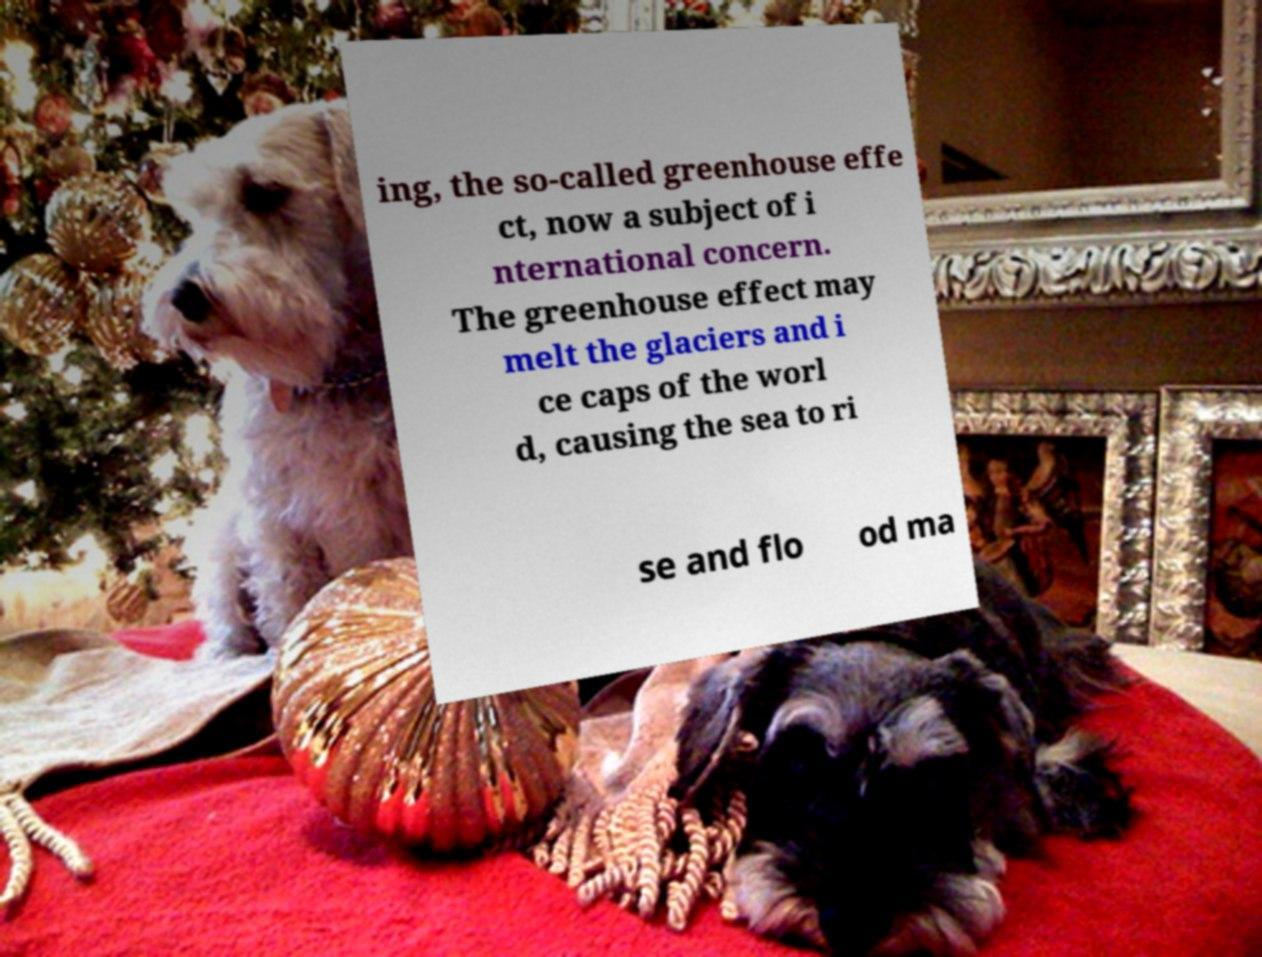Could you assist in decoding the text presented in this image and type it out clearly? ing, the so-called greenhouse effe ct, now a subject of i nternational concern. The greenhouse effect may melt the glaciers and i ce caps of the worl d, causing the sea to ri se and flo od ma 